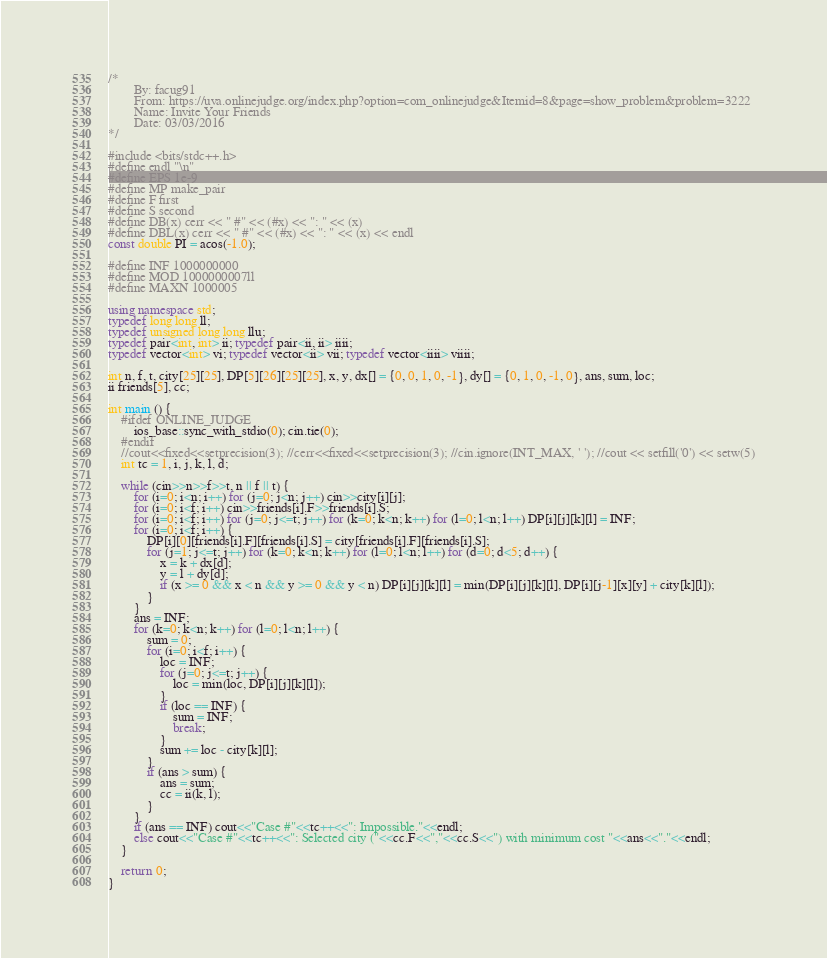Convert code to text. <code><loc_0><loc_0><loc_500><loc_500><_C++_>/*
        By: facug91
        From: https://uva.onlinejudge.org/index.php?option=com_onlinejudge&Itemid=8&page=show_problem&problem=3222
        Name: Invite Your Friends
        Date: 03/03/2016
*/

#include <bits/stdc++.h>
#define endl "\n"
#define EPS 1e-9
#define MP make_pair
#define F first
#define S second
#define DB(x) cerr << " #" << (#x) << ": " << (x)
#define DBL(x) cerr << " #" << (#x) << ": " << (x) << endl
const double PI = acos(-1.0);

#define INF 1000000000
#define MOD 1000000007ll
#define MAXN 1000005

using namespace std;
typedef long long ll;
typedef unsigned long long llu;
typedef pair<int, int> ii; typedef pair<ii, ii> iiii;
typedef vector<int> vi; typedef vector<ii> vii; typedef vector<iiii> viiii;

int n, f, t, city[25][25], DP[5][26][25][25], x, y, dx[] = {0, 0, 1, 0, -1}, dy[] = {0, 1, 0, -1, 0}, ans, sum, loc;
ii friends[5], cc;

int main () {
	#ifdef ONLINE_JUDGE
		ios_base::sync_with_stdio(0); cin.tie(0);
	#endif
	//cout<<fixed<<setprecision(3); //cerr<<fixed<<setprecision(3); //cin.ignore(INT_MAX, ' '); //cout << setfill('0') << setw(5)
	int tc = 1, i, j, k, l, d;
	
	while (cin>>n>>f>>t, n || f || t) {
		for (i=0; i<n; i++) for (j=0; j<n; j++) cin>>city[i][j];
		for (i=0; i<f; i++) cin>>friends[i].F>>friends[i].S;
		for (i=0; i<f; i++) for (j=0; j<=t; j++) for (k=0; k<n; k++) for (l=0; l<n; l++) DP[i][j][k][l] = INF;
		for (i=0; i<f; i++) {
			DP[i][0][friends[i].F][friends[i].S] = city[friends[i].F][friends[i].S];
			for (j=1; j<=t; j++) for (k=0; k<n; k++) for (l=0; l<n; l++) for (d=0; d<5; d++) {
				x = k + dx[d];
				y = l + dy[d];
				if (x >= 0 && x < n && y >= 0 && y < n) DP[i][j][k][l] = min(DP[i][j][k][l], DP[i][j-1][x][y] + city[k][l]);
			}
		}
		ans = INF;
		for (k=0; k<n; k++) for (l=0; l<n; l++) {
			sum = 0;
			for (i=0; i<f; i++) {
				loc = INF;
				for (j=0; j<=t; j++) {
					loc = min(loc, DP[i][j][k][l]);
				}
				if (loc == INF) {
					sum = INF;
					break;
				}
				sum += loc - city[k][l];
			}
			if (ans > sum) {
				ans = sum;
				cc = ii(k, l);
			}
		}
		if (ans == INF) cout<<"Case #"<<tc++<<": Impossible."<<endl;
		else cout<<"Case #"<<tc++<<": Selected city ("<<cc.F<<","<<cc.S<<") with minimum cost "<<ans<<"."<<endl;
	}
	
	return 0;
}
</code> 